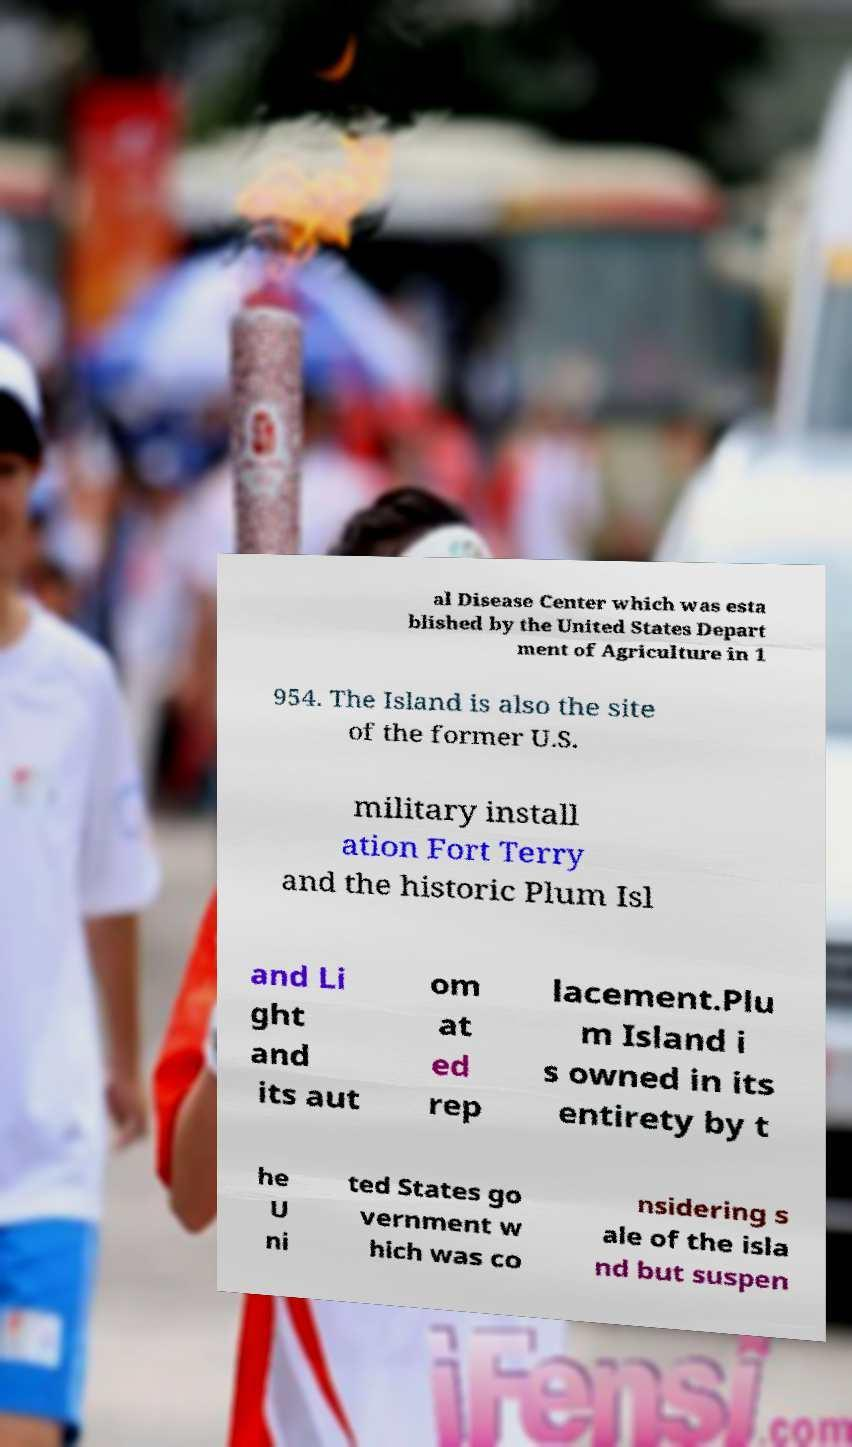Can you read and provide the text displayed in the image?This photo seems to have some interesting text. Can you extract and type it out for me? al Disease Center which was esta blished by the United States Depart ment of Agriculture in 1 954. The Island is also the site of the former U.S. military install ation Fort Terry and the historic Plum Isl and Li ght and its aut om at ed rep lacement.Plu m Island i s owned in its entirety by t he U ni ted States go vernment w hich was co nsidering s ale of the isla nd but suspen 